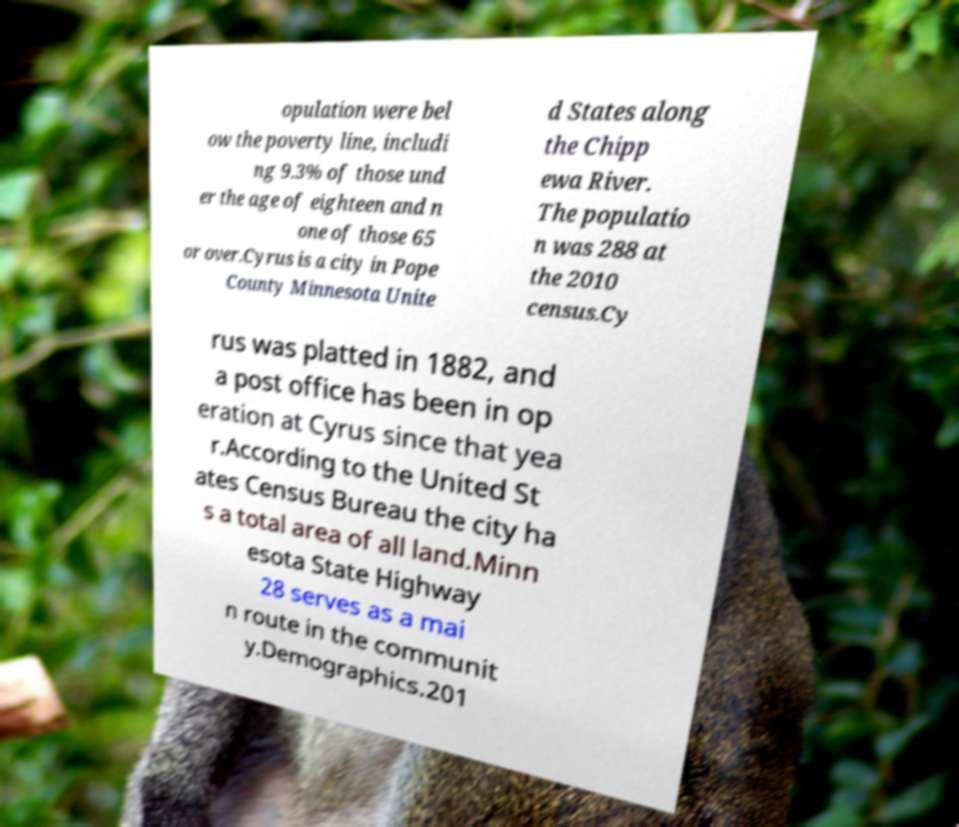Can you accurately transcribe the text from the provided image for me? opulation were bel ow the poverty line, includi ng 9.3% of those und er the age of eighteen and n one of those 65 or over.Cyrus is a city in Pope County Minnesota Unite d States along the Chipp ewa River. The populatio n was 288 at the 2010 census.Cy rus was platted in 1882, and a post office has been in op eration at Cyrus since that yea r.According to the United St ates Census Bureau the city ha s a total area of all land.Minn esota State Highway 28 serves as a mai n route in the communit y.Demographics.201 